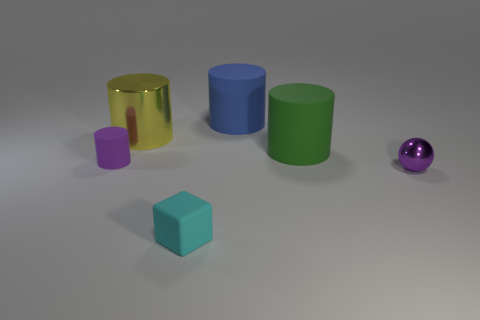Add 3 blue blocks. How many objects exist? 9 Subtract all cylinders. How many objects are left? 2 Subtract all big green metallic objects. Subtract all tiny metallic things. How many objects are left? 5 Add 2 big yellow objects. How many big yellow objects are left? 3 Add 6 metal objects. How many metal objects exist? 8 Subtract 1 purple cylinders. How many objects are left? 5 